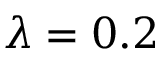<formula> <loc_0><loc_0><loc_500><loc_500>\lambda = 0 . 2</formula> 